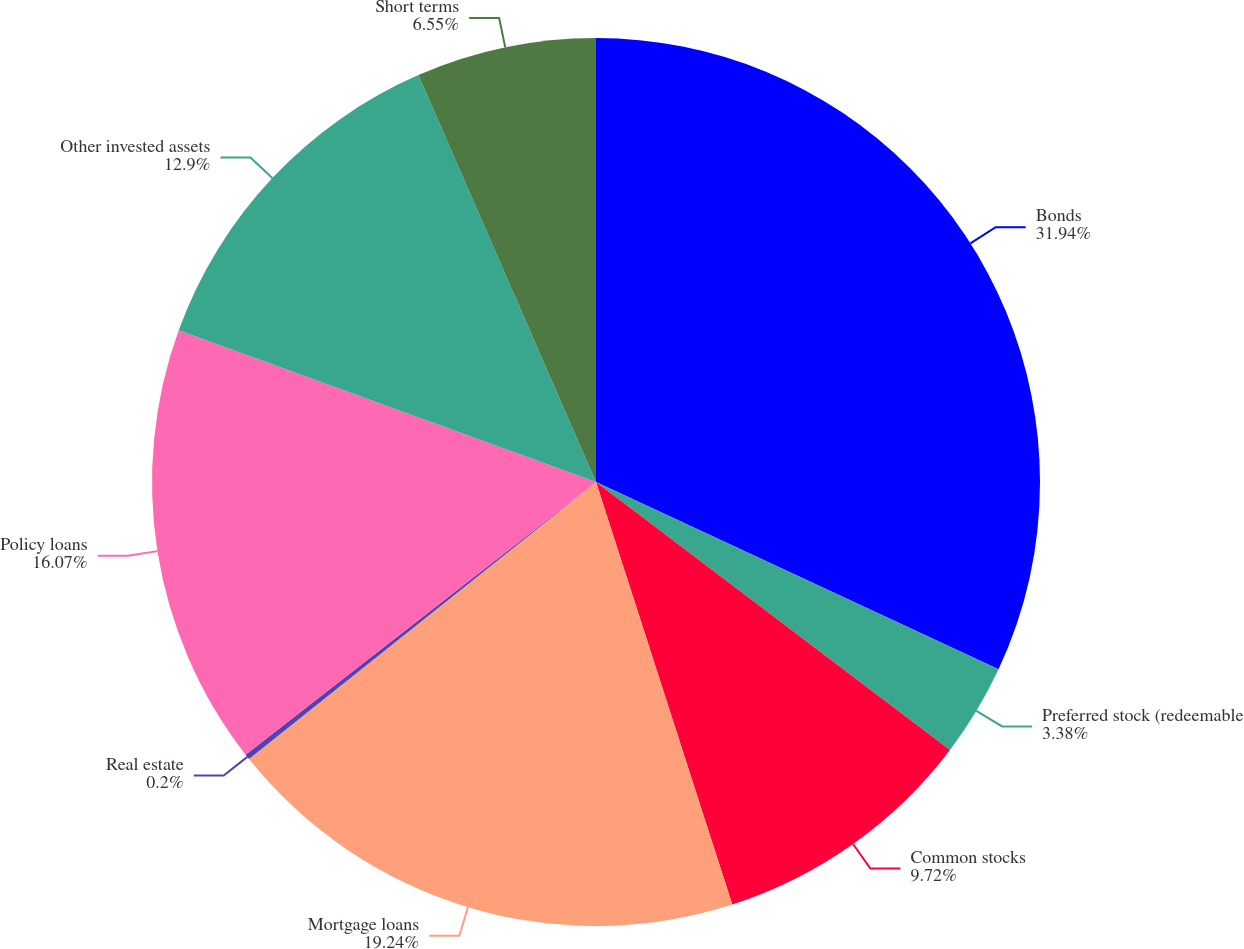Convert chart. <chart><loc_0><loc_0><loc_500><loc_500><pie_chart><fcel>Bonds<fcel>Preferred stock (redeemable<fcel>Common stocks<fcel>Mortgage loans<fcel>Real estate<fcel>Policy loans<fcel>Other invested assets<fcel>Short terms<nl><fcel>31.93%<fcel>3.38%<fcel>9.72%<fcel>19.24%<fcel>0.2%<fcel>16.07%<fcel>12.9%<fcel>6.55%<nl></chart> 